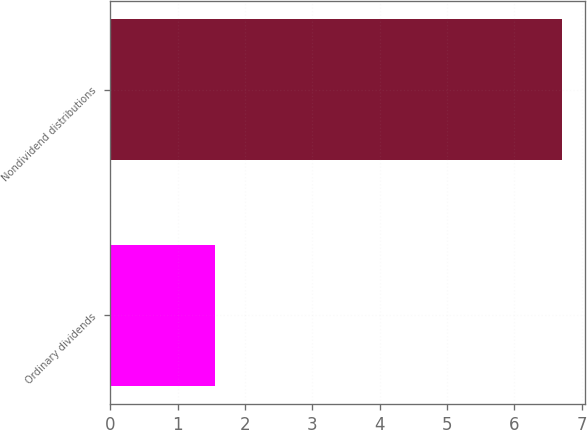<chart> <loc_0><loc_0><loc_500><loc_500><bar_chart><fcel>Ordinary dividends<fcel>Nondividend distributions<nl><fcel>1.56<fcel>6.71<nl></chart> 